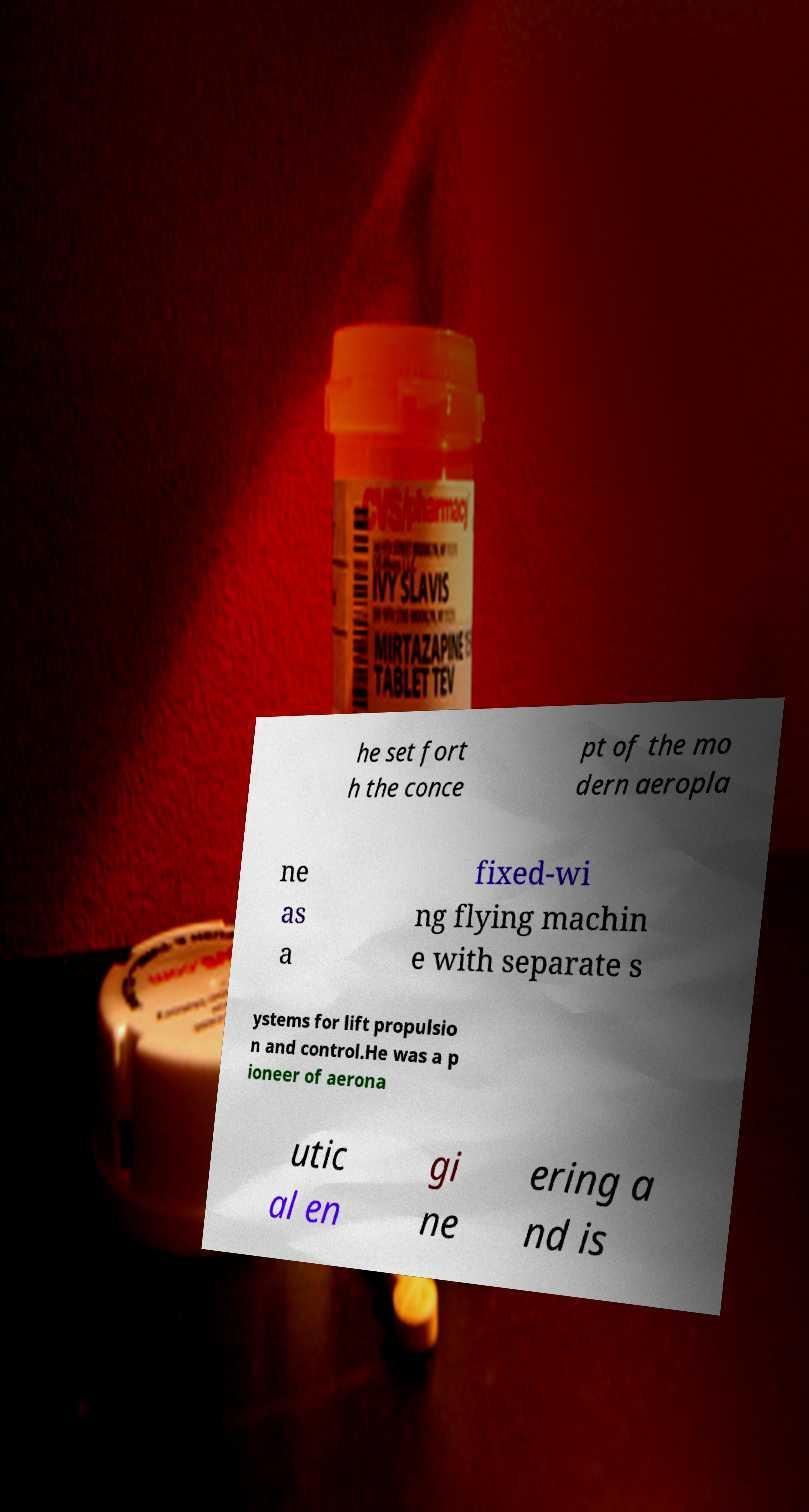Can you read and provide the text displayed in the image?This photo seems to have some interesting text. Can you extract and type it out for me? he set fort h the conce pt of the mo dern aeropla ne as a fixed-wi ng flying machin e with separate s ystems for lift propulsio n and control.He was a p ioneer of aerona utic al en gi ne ering a nd is 